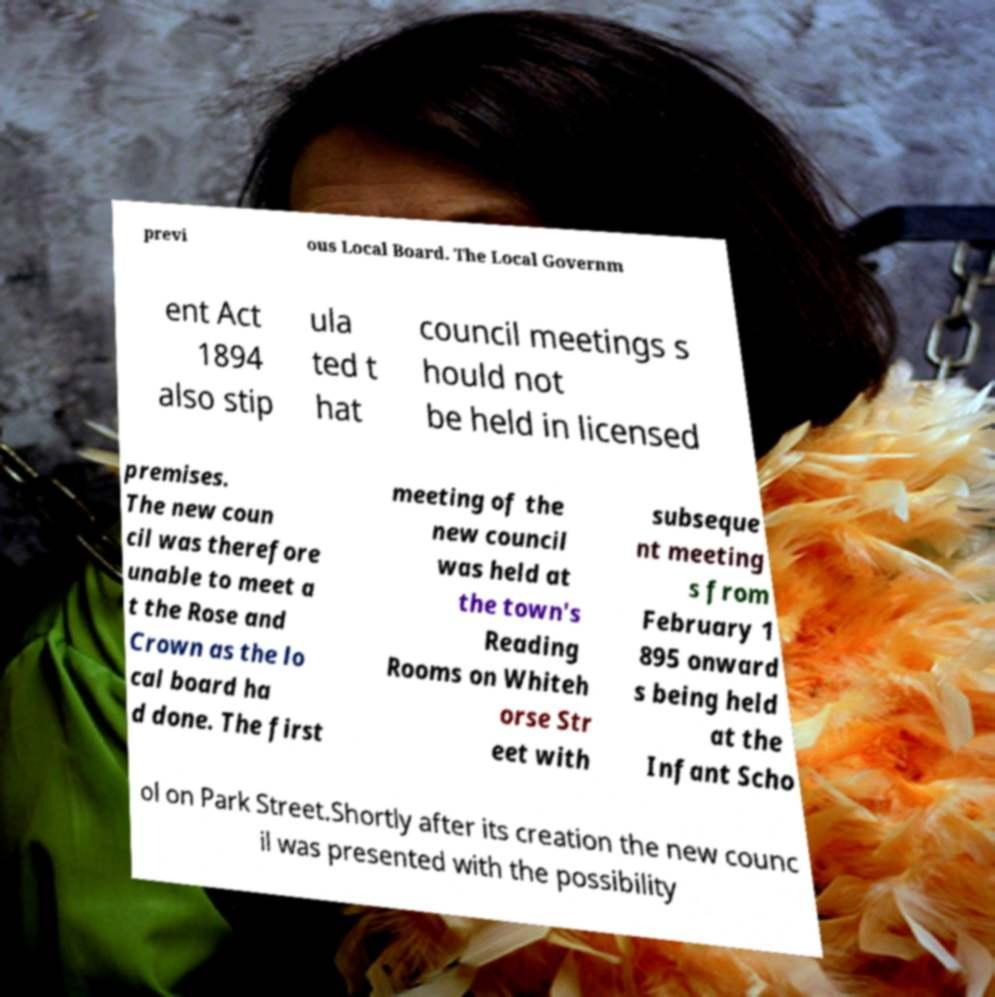Could you extract and type out the text from this image? previ ous Local Board. The Local Governm ent Act 1894 also stip ula ted t hat council meetings s hould not be held in licensed premises. The new coun cil was therefore unable to meet a t the Rose and Crown as the lo cal board ha d done. The first meeting of the new council was held at the town's Reading Rooms on Whiteh orse Str eet with subseque nt meeting s from February 1 895 onward s being held at the Infant Scho ol on Park Street.Shortly after its creation the new counc il was presented with the possibility 